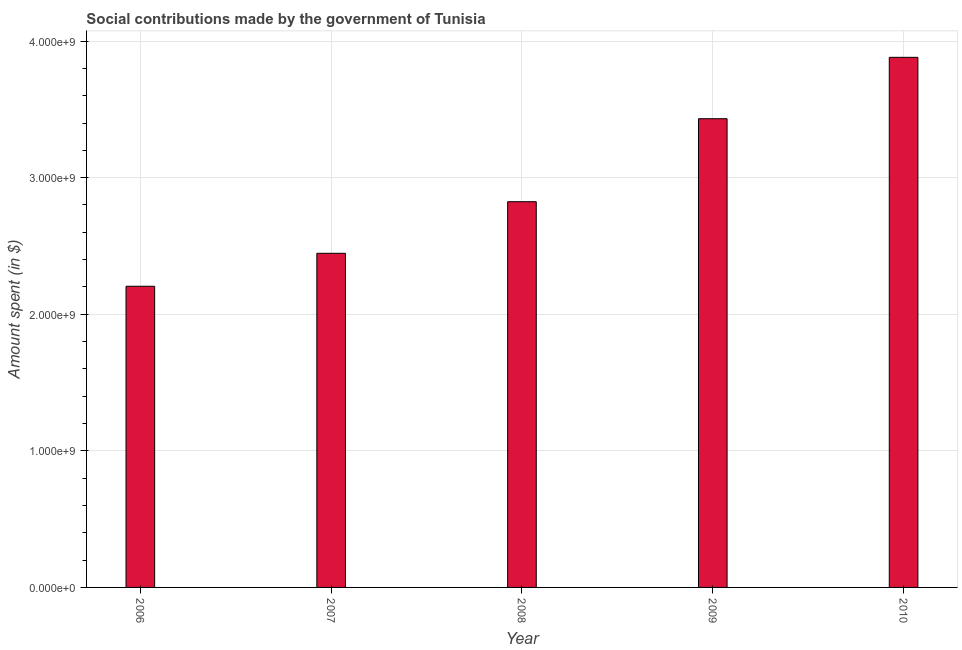Does the graph contain any zero values?
Your response must be concise. No. What is the title of the graph?
Your answer should be very brief. Social contributions made by the government of Tunisia. What is the label or title of the Y-axis?
Ensure brevity in your answer.  Amount spent (in $). What is the amount spent in making social contributions in 2010?
Your response must be concise. 3.88e+09. Across all years, what is the maximum amount spent in making social contributions?
Keep it short and to the point. 3.88e+09. Across all years, what is the minimum amount spent in making social contributions?
Provide a succinct answer. 2.20e+09. In which year was the amount spent in making social contributions maximum?
Offer a terse response. 2010. In which year was the amount spent in making social contributions minimum?
Offer a terse response. 2006. What is the sum of the amount spent in making social contributions?
Keep it short and to the point. 1.48e+1. What is the difference between the amount spent in making social contributions in 2006 and 2008?
Offer a very short reply. -6.19e+08. What is the average amount spent in making social contributions per year?
Your answer should be compact. 2.96e+09. What is the median amount spent in making social contributions?
Offer a very short reply. 2.82e+09. In how many years, is the amount spent in making social contributions greater than 1800000000 $?
Your answer should be very brief. 5. What is the ratio of the amount spent in making social contributions in 2007 to that in 2010?
Give a very brief answer. 0.63. Is the difference between the amount spent in making social contributions in 2006 and 2007 greater than the difference between any two years?
Keep it short and to the point. No. What is the difference between the highest and the second highest amount spent in making social contributions?
Keep it short and to the point. 4.49e+08. Is the sum of the amount spent in making social contributions in 2009 and 2010 greater than the maximum amount spent in making social contributions across all years?
Your response must be concise. Yes. What is the difference between the highest and the lowest amount spent in making social contributions?
Provide a short and direct response. 1.68e+09. Are all the bars in the graph horizontal?
Make the answer very short. No. How many years are there in the graph?
Your answer should be compact. 5. Are the values on the major ticks of Y-axis written in scientific E-notation?
Offer a terse response. Yes. What is the Amount spent (in $) of 2006?
Your answer should be very brief. 2.20e+09. What is the Amount spent (in $) of 2007?
Make the answer very short. 2.45e+09. What is the Amount spent (in $) in 2008?
Provide a short and direct response. 2.82e+09. What is the Amount spent (in $) in 2009?
Ensure brevity in your answer.  3.43e+09. What is the Amount spent (in $) in 2010?
Your response must be concise. 3.88e+09. What is the difference between the Amount spent (in $) in 2006 and 2007?
Keep it short and to the point. -2.41e+08. What is the difference between the Amount spent (in $) in 2006 and 2008?
Make the answer very short. -6.19e+08. What is the difference between the Amount spent (in $) in 2006 and 2009?
Provide a short and direct response. -1.23e+09. What is the difference between the Amount spent (in $) in 2006 and 2010?
Ensure brevity in your answer.  -1.68e+09. What is the difference between the Amount spent (in $) in 2007 and 2008?
Make the answer very short. -3.78e+08. What is the difference between the Amount spent (in $) in 2007 and 2009?
Make the answer very short. -9.85e+08. What is the difference between the Amount spent (in $) in 2007 and 2010?
Your answer should be compact. -1.43e+09. What is the difference between the Amount spent (in $) in 2008 and 2009?
Your answer should be very brief. -6.08e+08. What is the difference between the Amount spent (in $) in 2008 and 2010?
Provide a short and direct response. -1.06e+09. What is the difference between the Amount spent (in $) in 2009 and 2010?
Provide a short and direct response. -4.49e+08. What is the ratio of the Amount spent (in $) in 2006 to that in 2007?
Offer a terse response. 0.9. What is the ratio of the Amount spent (in $) in 2006 to that in 2008?
Offer a terse response. 0.78. What is the ratio of the Amount spent (in $) in 2006 to that in 2009?
Offer a very short reply. 0.64. What is the ratio of the Amount spent (in $) in 2006 to that in 2010?
Your response must be concise. 0.57. What is the ratio of the Amount spent (in $) in 2007 to that in 2008?
Offer a terse response. 0.87. What is the ratio of the Amount spent (in $) in 2007 to that in 2009?
Your answer should be compact. 0.71. What is the ratio of the Amount spent (in $) in 2007 to that in 2010?
Keep it short and to the point. 0.63. What is the ratio of the Amount spent (in $) in 2008 to that in 2009?
Your answer should be very brief. 0.82. What is the ratio of the Amount spent (in $) in 2008 to that in 2010?
Your answer should be compact. 0.73. What is the ratio of the Amount spent (in $) in 2009 to that in 2010?
Provide a short and direct response. 0.88. 